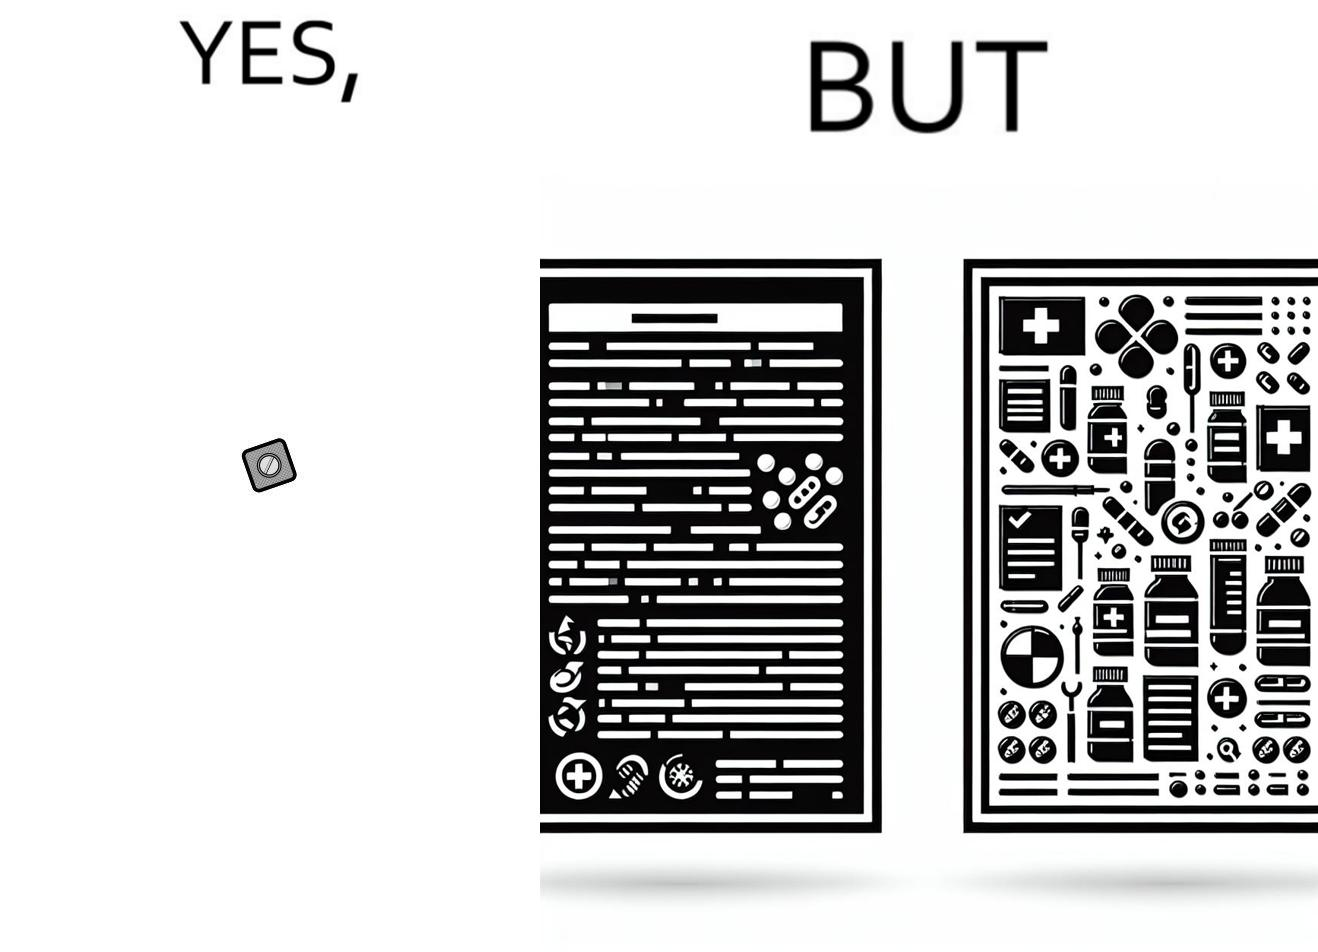Provide a description of this image. the irony in this image is a small thing like a medicine very often has instructions and a manual that is extremely long 